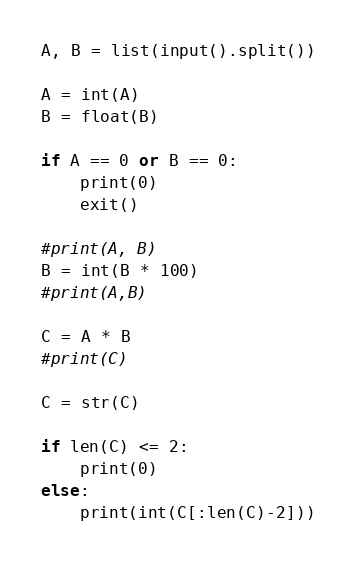Convert code to text. <code><loc_0><loc_0><loc_500><loc_500><_Python_>A, B = list(input().split())

A = int(A)
B = float(B)

if A == 0 or B == 0:
    print(0)
    exit()

#print(A, B)
B = int(B * 100)
#print(A,B)

C = A * B
#print(C)

C = str(C)

if len(C) <= 2:
    print(0)
else:
    print(int(C[:len(C)-2]))</code> 